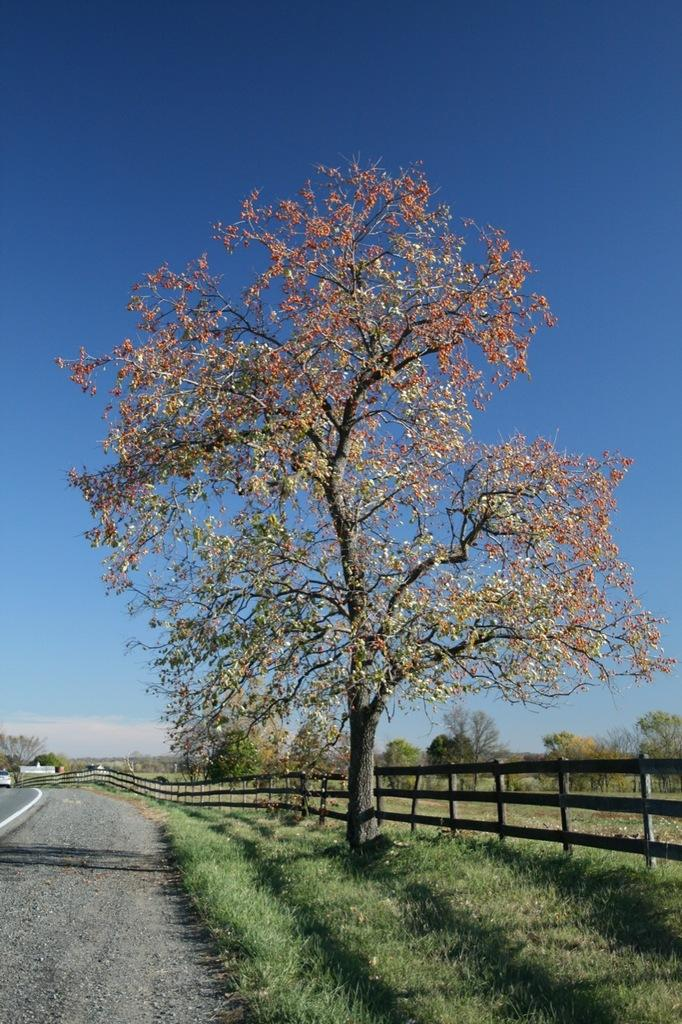What can be seen in the foreground of the picture? In the foreground of the picture, there are railings, trees, grass, and a road. What is visible in the background of the picture? In the background of the picture, there are houses, trees, and fields. What is the weather like in the image? The sky is sunny, indicating a clear and likely warm day. Reasoning: Let'ing: Let's think step by step in order to produce the conversation. We start by identifying the main subjects and objects in the image based on the provided facts. We then formulate questions that focus on the location and characteristics of these subjects and objects, ensuring that each question can be answered definitively with the information given. We avoid yes/no questions and ensure that the language is simple and clear. Absurd Question/Answer: What type of debt is being discussed in the image? There is no mention of debt in the image; it features a landscape with railings, trees, grass, a road, houses, trees, fields, and a sunny sky. What kind of cast is present in the image? There is no cast present in the image; it is a photograph of a landscape. 